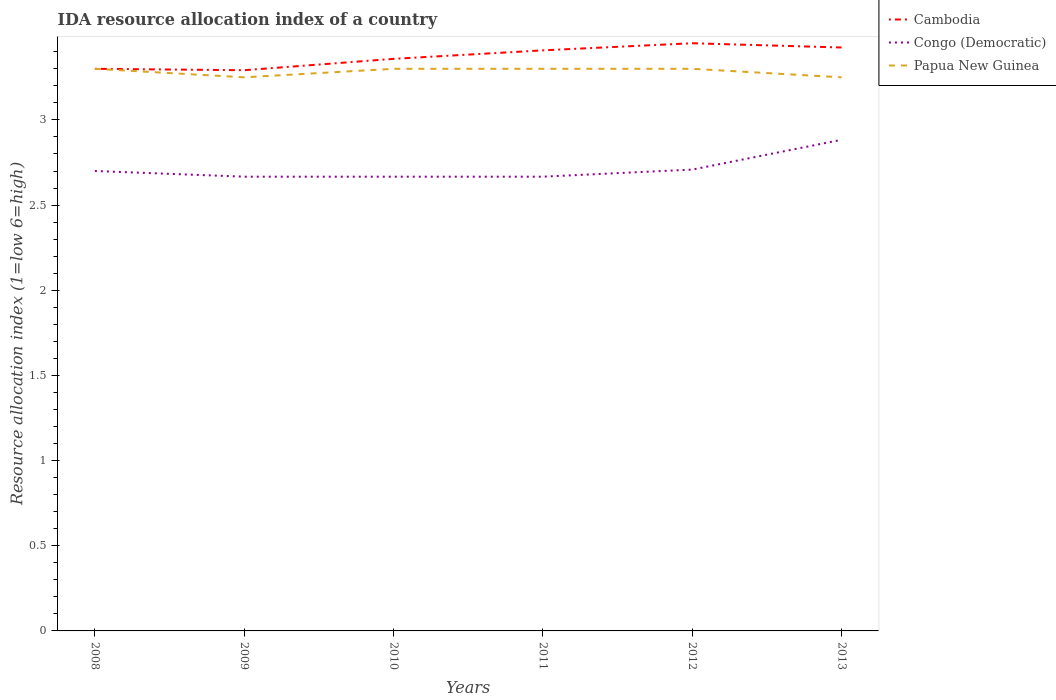How many different coloured lines are there?
Provide a short and direct response. 3. Is the number of lines equal to the number of legend labels?
Your response must be concise. Yes. Across all years, what is the maximum IDA resource allocation index in Papua New Guinea?
Offer a very short reply. 3.25. What is the total IDA resource allocation index in Congo (Democratic) in the graph?
Give a very brief answer. 0.03. What is the difference between the highest and the second highest IDA resource allocation index in Cambodia?
Your answer should be very brief. 0.16. What is the difference between the highest and the lowest IDA resource allocation index in Congo (Democratic)?
Offer a very short reply. 1. How many lines are there?
Your answer should be compact. 3. How many years are there in the graph?
Give a very brief answer. 6. Does the graph contain any zero values?
Offer a terse response. No. Where does the legend appear in the graph?
Offer a terse response. Top right. What is the title of the graph?
Give a very brief answer. IDA resource allocation index of a country. What is the label or title of the Y-axis?
Provide a succinct answer. Resource allocation index (1=low 6=high). What is the Resource allocation index (1=low 6=high) of Congo (Democratic) in 2008?
Give a very brief answer. 2.7. What is the Resource allocation index (1=low 6=high) in Cambodia in 2009?
Provide a succinct answer. 3.29. What is the Resource allocation index (1=low 6=high) of Congo (Democratic) in 2009?
Keep it short and to the point. 2.67. What is the Resource allocation index (1=low 6=high) of Cambodia in 2010?
Ensure brevity in your answer.  3.36. What is the Resource allocation index (1=low 6=high) of Congo (Democratic) in 2010?
Ensure brevity in your answer.  2.67. What is the Resource allocation index (1=low 6=high) in Papua New Guinea in 2010?
Your response must be concise. 3.3. What is the Resource allocation index (1=low 6=high) in Cambodia in 2011?
Keep it short and to the point. 3.41. What is the Resource allocation index (1=low 6=high) in Congo (Democratic) in 2011?
Your response must be concise. 2.67. What is the Resource allocation index (1=low 6=high) in Cambodia in 2012?
Your answer should be compact. 3.45. What is the Resource allocation index (1=low 6=high) of Congo (Democratic) in 2012?
Provide a short and direct response. 2.71. What is the Resource allocation index (1=low 6=high) of Cambodia in 2013?
Offer a very short reply. 3.42. What is the Resource allocation index (1=low 6=high) of Congo (Democratic) in 2013?
Your answer should be very brief. 2.88. Across all years, what is the maximum Resource allocation index (1=low 6=high) of Cambodia?
Provide a short and direct response. 3.45. Across all years, what is the maximum Resource allocation index (1=low 6=high) in Congo (Democratic)?
Ensure brevity in your answer.  2.88. Across all years, what is the minimum Resource allocation index (1=low 6=high) in Cambodia?
Make the answer very short. 3.29. Across all years, what is the minimum Resource allocation index (1=low 6=high) in Congo (Democratic)?
Your answer should be very brief. 2.67. Across all years, what is the minimum Resource allocation index (1=low 6=high) in Papua New Guinea?
Your response must be concise. 3.25. What is the total Resource allocation index (1=low 6=high) in Cambodia in the graph?
Offer a very short reply. 20.23. What is the total Resource allocation index (1=low 6=high) of Congo (Democratic) in the graph?
Offer a very short reply. 16.29. What is the total Resource allocation index (1=low 6=high) of Papua New Guinea in the graph?
Your answer should be very brief. 19.7. What is the difference between the Resource allocation index (1=low 6=high) in Cambodia in 2008 and that in 2009?
Provide a succinct answer. 0.01. What is the difference between the Resource allocation index (1=low 6=high) in Papua New Guinea in 2008 and that in 2009?
Your answer should be compact. 0.05. What is the difference between the Resource allocation index (1=low 6=high) of Cambodia in 2008 and that in 2010?
Provide a short and direct response. -0.06. What is the difference between the Resource allocation index (1=low 6=high) in Papua New Guinea in 2008 and that in 2010?
Your response must be concise. 0. What is the difference between the Resource allocation index (1=low 6=high) in Cambodia in 2008 and that in 2011?
Your answer should be compact. -0.11. What is the difference between the Resource allocation index (1=low 6=high) of Congo (Democratic) in 2008 and that in 2011?
Provide a succinct answer. 0.03. What is the difference between the Resource allocation index (1=low 6=high) in Congo (Democratic) in 2008 and that in 2012?
Give a very brief answer. -0.01. What is the difference between the Resource allocation index (1=low 6=high) of Cambodia in 2008 and that in 2013?
Your answer should be very brief. -0.12. What is the difference between the Resource allocation index (1=low 6=high) of Congo (Democratic) in 2008 and that in 2013?
Your response must be concise. -0.18. What is the difference between the Resource allocation index (1=low 6=high) in Papua New Guinea in 2008 and that in 2013?
Keep it short and to the point. 0.05. What is the difference between the Resource allocation index (1=low 6=high) in Cambodia in 2009 and that in 2010?
Keep it short and to the point. -0.07. What is the difference between the Resource allocation index (1=low 6=high) in Congo (Democratic) in 2009 and that in 2010?
Your response must be concise. 0. What is the difference between the Resource allocation index (1=low 6=high) in Cambodia in 2009 and that in 2011?
Offer a terse response. -0.12. What is the difference between the Resource allocation index (1=low 6=high) in Papua New Guinea in 2009 and that in 2011?
Make the answer very short. -0.05. What is the difference between the Resource allocation index (1=low 6=high) of Cambodia in 2009 and that in 2012?
Give a very brief answer. -0.16. What is the difference between the Resource allocation index (1=low 6=high) in Congo (Democratic) in 2009 and that in 2012?
Keep it short and to the point. -0.04. What is the difference between the Resource allocation index (1=low 6=high) in Papua New Guinea in 2009 and that in 2012?
Your answer should be compact. -0.05. What is the difference between the Resource allocation index (1=low 6=high) in Cambodia in 2009 and that in 2013?
Give a very brief answer. -0.13. What is the difference between the Resource allocation index (1=low 6=high) of Congo (Democratic) in 2009 and that in 2013?
Your answer should be very brief. -0.22. What is the difference between the Resource allocation index (1=low 6=high) in Papua New Guinea in 2009 and that in 2013?
Make the answer very short. 0. What is the difference between the Resource allocation index (1=low 6=high) in Cambodia in 2010 and that in 2011?
Your answer should be compact. -0.05. What is the difference between the Resource allocation index (1=low 6=high) of Papua New Guinea in 2010 and that in 2011?
Give a very brief answer. 0. What is the difference between the Resource allocation index (1=low 6=high) in Cambodia in 2010 and that in 2012?
Provide a short and direct response. -0.09. What is the difference between the Resource allocation index (1=low 6=high) of Congo (Democratic) in 2010 and that in 2012?
Ensure brevity in your answer.  -0.04. What is the difference between the Resource allocation index (1=low 6=high) of Papua New Guinea in 2010 and that in 2012?
Keep it short and to the point. 0. What is the difference between the Resource allocation index (1=low 6=high) of Cambodia in 2010 and that in 2013?
Your answer should be very brief. -0.07. What is the difference between the Resource allocation index (1=low 6=high) in Congo (Democratic) in 2010 and that in 2013?
Make the answer very short. -0.22. What is the difference between the Resource allocation index (1=low 6=high) of Cambodia in 2011 and that in 2012?
Keep it short and to the point. -0.04. What is the difference between the Resource allocation index (1=low 6=high) in Congo (Democratic) in 2011 and that in 2012?
Offer a terse response. -0.04. What is the difference between the Resource allocation index (1=low 6=high) of Papua New Guinea in 2011 and that in 2012?
Your answer should be compact. 0. What is the difference between the Resource allocation index (1=low 6=high) of Cambodia in 2011 and that in 2013?
Your response must be concise. -0.02. What is the difference between the Resource allocation index (1=low 6=high) of Congo (Democratic) in 2011 and that in 2013?
Your answer should be compact. -0.22. What is the difference between the Resource allocation index (1=low 6=high) in Cambodia in 2012 and that in 2013?
Provide a succinct answer. 0.03. What is the difference between the Resource allocation index (1=low 6=high) in Congo (Democratic) in 2012 and that in 2013?
Ensure brevity in your answer.  -0.17. What is the difference between the Resource allocation index (1=low 6=high) in Papua New Guinea in 2012 and that in 2013?
Provide a short and direct response. 0.05. What is the difference between the Resource allocation index (1=low 6=high) in Cambodia in 2008 and the Resource allocation index (1=low 6=high) in Congo (Democratic) in 2009?
Offer a very short reply. 0.63. What is the difference between the Resource allocation index (1=low 6=high) of Cambodia in 2008 and the Resource allocation index (1=low 6=high) of Papua New Guinea in 2009?
Ensure brevity in your answer.  0.05. What is the difference between the Resource allocation index (1=low 6=high) of Congo (Democratic) in 2008 and the Resource allocation index (1=low 6=high) of Papua New Guinea in 2009?
Your answer should be very brief. -0.55. What is the difference between the Resource allocation index (1=low 6=high) of Cambodia in 2008 and the Resource allocation index (1=low 6=high) of Congo (Democratic) in 2010?
Ensure brevity in your answer.  0.63. What is the difference between the Resource allocation index (1=low 6=high) of Cambodia in 2008 and the Resource allocation index (1=low 6=high) of Papua New Guinea in 2010?
Offer a terse response. 0. What is the difference between the Resource allocation index (1=low 6=high) of Congo (Democratic) in 2008 and the Resource allocation index (1=low 6=high) of Papua New Guinea in 2010?
Offer a terse response. -0.6. What is the difference between the Resource allocation index (1=low 6=high) of Cambodia in 2008 and the Resource allocation index (1=low 6=high) of Congo (Democratic) in 2011?
Offer a very short reply. 0.63. What is the difference between the Resource allocation index (1=low 6=high) in Cambodia in 2008 and the Resource allocation index (1=low 6=high) in Congo (Democratic) in 2012?
Provide a short and direct response. 0.59. What is the difference between the Resource allocation index (1=low 6=high) of Congo (Democratic) in 2008 and the Resource allocation index (1=low 6=high) of Papua New Guinea in 2012?
Your response must be concise. -0.6. What is the difference between the Resource allocation index (1=low 6=high) in Cambodia in 2008 and the Resource allocation index (1=low 6=high) in Congo (Democratic) in 2013?
Your response must be concise. 0.42. What is the difference between the Resource allocation index (1=low 6=high) of Congo (Democratic) in 2008 and the Resource allocation index (1=low 6=high) of Papua New Guinea in 2013?
Offer a very short reply. -0.55. What is the difference between the Resource allocation index (1=low 6=high) in Cambodia in 2009 and the Resource allocation index (1=low 6=high) in Congo (Democratic) in 2010?
Keep it short and to the point. 0.62. What is the difference between the Resource allocation index (1=low 6=high) in Cambodia in 2009 and the Resource allocation index (1=low 6=high) in Papua New Guinea in 2010?
Your answer should be very brief. -0.01. What is the difference between the Resource allocation index (1=low 6=high) in Congo (Democratic) in 2009 and the Resource allocation index (1=low 6=high) in Papua New Guinea in 2010?
Make the answer very short. -0.63. What is the difference between the Resource allocation index (1=low 6=high) in Cambodia in 2009 and the Resource allocation index (1=low 6=high) in Papua New Guinea in 2011?
Make the answer very short. -0.01. What is the difference between the Resource allocation index (1=low 6=high) in Congo (Democratic) in 2009 and the Resource allocation index (1=low 6=high) in Papua New Guinea in 2011?
Your answer should be compact. -0.63. What is the difference between the Resource allocation index (1=low 6=high) of Cambodia in 2009 and the Resource allocation index (1=low 6=high) of Congo (Democratic) in 2012?
Make the answer very short. 0.58. What is the difference between the Resource allocation index (1=low 6=high) of Cambodia in 2009 and the Resource allocation index (1=low 6=high) of Papua New Guinea in 2012?
Keep it short and to the point. -0.01. What is the difference between the Resource allocation index (1=low 6=high) of Congo (Democratic) in 2009 and the Resource allocation index (1=low 6=high) of Papua New Guinea in 2012?
Your answer should be very brief. -0.63. What is the difference between the Resource allocation index (1=low 6=high) in Cambodia in 2009 and the Resource allocation index (1=low 6=high) in Congo (Democratic) in 2013?
Provide a succinct answer. 0.41. What is the difference between the Resource allocation index (1=low 6=high) of Cambodia in 2009 and the Resource allocation index (1=low 6=high) of Papua New Guinea in 2013?
Offer a very short reply. 0.04. What is the difference between the Resource allocation index (1=low 6=high) in Congo (Democratic) in 2009 and the Resource allocation index (1=low 6=high) in Papua New Guinea in 2013?
Offer a terse response. -0.58. What is the difference between the Resource allocation index (1=low 6=high) of Cambodia in 2010 and the Resource allocation index (1=low 6=high) of Congo (Democratic) in 2011?
Your answer should be compact. 0.69. What is the difference between the Resource allocation index (1=low 6=high) of Cambodia in 2010 and the Resource allocation index (1=low 6=high) of Papua New Guinea in 2011?
Offer a very short reply. 0.06. What is the difference between the Resource allocation index (1=low 6=high) of Congo (Democratic) in 2010 and the Resource allocation index (1=low 6=high) of Papua New Guinea in 2011?
Your answer should be very brief. -0.63. What is the difference between the Resource allocation index (1=low 6=high) of Cambodia in 2010 and the Resource allocation index (1=low 6=high) of Congo (Democratic) in 2012?
Offer a very short reply. 0.65. What is the difference between the Resource allocation index (1=low 6=high) of Cambodia in 2010 and the Resource allocation index (1=low 6=high) of Papua New Guinea in 2012?
Ensure brevity in your answer.  0.06. What is the difference between the Resource allocation index (1=low 6=high) of Congo (Democratic) in 2010 and the Resource allocation index (1=low 6=high) of Papua New Guinea in 2012?
Offer a very short reply. -0.63. What is the difference between the Resource allocation index (1=low 6=high) of Cambodia in 2010 and the Resource allocation index (1=low 6=high) of Congo (Democratic) in 2013?
Your answer should be compact. 0.47. What is the difference between the Resource allocation index (1=low 6=high) in Cambodia in 2010 and the Resource allocation index (1=low 6=high) in Papua New Guinea in 2013?
Ensure brevity in your answer.  0.11. What is the difference between the Resource allocation index (1=low 6=high) of Congo (Democratic) in 2010 and the Resource allocation index (1=low 6=high) of Papua New Guinea in 2013?
Give a very brief answer. -0.58. What is the difference between the Resource allocation index (1=low 6=high) of Cambodia in 2011 and the Resource allocation index (1=low 6=high) of Congo (Democratic) in 2012?
Ensure brevity in your answer.  0.7. What is the difference between the Resource allocation index (1=low 6=high) of Cambodia in 2011 and the Resource allocation index (1=low 6=high) of Papua New Guinea in 2012?
Offer a very short reply. 0.11. What is the difference between the Resource allocation index (1=low 6=high) in Congo (Democratic) in 2011 and the Resource allocation index (1=low 6=high) in Papua New Guinea in 2012?
Ensure brevity in your answer.  -0.63. What is the difference between the Resource allocation index (1=low 6=high) of Cambodia in 2011 and the Resource allocation index (1=low 6=high) of Congo (Democratic) in 2013?
Your response must be concise. 0.53. What is the difference between the Resource allocation index (1=low 6=high) in Cambodia in 2011 and the Resource allocation index (1=low 6=high) in Papua New Guinea in 2013?
Provide a short and direct response. 0.16. What is the difference between the Resource allocation index (1=low 6=high) of Congo (Democratic) in 2011 and the Resource allocation index (1=low 6=high) of Papua New Guinea in 2013?
Provide a succinct answer. -0.58. What is the difference between the Resource allocation index (1=low 6=high) in Cambodia in 2012 and the Resource allocation index (1=low 6=high) in Congo (Democratic) in 2013?
Provide a succinct answer. 0.57. What is the difference between the Resource allocation index (1=low 6=high) in Congo (Democratic) in 2012 and the Resource allocation index (1=low 6=high) in Papua New Guinea in 2013?
Offer a terse response. -0.54. What is the average Resource allocation index (1=low 6=high) in Cambodia per year?
Provide a succinct answer. 3.37. What is the average Resource allocation index (1=low 6=high) in Congo (Democratic) per year?
Provide a short and direct response. 2.72. What is the average Resource allocation index (1=low 6=high) of Papua New Guinea per year?
Your answer should be compact. 3.28. In the year 2008, what is the difference between the Resource allocation index (1=low 6=high) of Cambodia and Resource allocation index (1=low 6=high) of Papua New Guinea?
Ensure brevity in your answer.  0. In the year 2009, what is the difference between the Resource allocation index (1=low 6=high) in Cambodia and Resource allocation index (1=low 6=high) in Congo (Democratic)?
Make the answer very short. 0.62. In the year 2009, what is the difference between the Resource allocation index (1=low 6=high) in Cambodia and Resource allocation index (1=low 6=high) in Papua New Guinea?
Ensure brevity in your answer.  0.04. In the year 2009, what is the difference between the Resource allocation index (1=low 6=high) of Congo (Democratic) and Resource allocation index (1=low 6=high) of Papua New Guinea?
Offer a terse response. -0.58. In the year 2010, what is the difference between the Resource allocation index (1=low 6=high) of Cambodia and Resource allocation index (1=low 6=high) of Congo (Democratic)?
Provide a succinct answer. 0.69. In the year 2010, what is the difference between the Resource allocation index (1=low 6=high) in Cambodia and Resource allocation index (1=low 6=high) in Papua New Guinea?
Provide a succinct answer. 0.06. In the year 2010, what is the difference between the Resource allocation index (1=low 6=high) of Congo (Democratic) and Resource allocation index (1=low 6=high) of Papua New Guinea?
Offer a terse response. -0.63. In the year 2011, what is the difference between the Resource allocation index (1=low 6=high) in Cambodia and Resource allocation index (1=low 6=high) in Congo (Democratic)?
Offer a very short reply. 0.74. In the year 2011, what is the difference between the Resource allocation index (1=low 6=high) of Cambodia and Resource allocation index (1=low 6=high) of Papua New Guinea?
Keep it short and to the point. 0.11. In the year 2011, what is the difference between the Resource allocation index (1=low 6=high) of Congo (Democratic) and Resource allocation index (1=low 6=high) of Papua New Guinea?
Make the answer very short. -0.63. In the year 2012, what is the difference between the Resource allocation index (1=low 6=high) in Cambodia and Resource allocation index (1=low 6=high) in Congo (Democratic)?
Your response must be concise. 0.74. In the year 2012, what is the difference between the Resource allocation index (1=low 6=high) in Congo (Democratic) and Resource allocation index (1=low 6=high) in Papua New Guinea?
Offer a terse response. -0.59. In the year 2013, what is the difference between the Resource allocation index (1=low 6=high) in Cambodia and Resource allocation index (1=low 6=high) in Congo (Democratic)?
Offer a very short reply. 0.54. In the year 2013, what is the difference between the Resource allocation index (1=low 6=high) of Cambodia and Resource allocation index (1=low 6=high) of Papua New Guinea?
Provide a short and direct response. 0.17. In the year 2013, what is the difference between the Resource allocation index (1=low 6=high) of Congo (Democratic) and Resource allocation index (1=low 6=high) of Papua New Guinea?
Offer a terse response. -0.37. What is the ratio of the Resource allocation index (1=low 6=high) in Congo (Democratic) in 2008 to that in 2009?
Offer a very short reply. 1.01. What is the ratio of the Resource allocation index (1=low 6=high) in Papua New Guinea in 2008 to that in 2009?
Keep it short and to the point. 1.02. What is the ratio of the Resource allocation index (1=low 6=high) in Cambodia in 2008 to that in 2010?
Ensure brevity in your answer.  0.98. What is the ratio of the Resource allocation index (1=low 6=high) of Congo (Democratic) in 2008 to that in 2010?
Ensure brevity in your answer.  1.01. What is the ratio of the Resource allocation index (1=low 6=high) of Cambodia in 2008 to that in 2011?
Make the answer very short. 0.97. What is the ratio of the Resource allocation index (1=low 6=high) of Congo (Democratic) in 2008 to that in 2011?
Make the answer very short. 1.01. What is the ratio of the Resource allocation index (1=low 6=high) of Papua New Guinea in 2008 to that in 2011?
Offer a very short reply. 1. What is the ratio of the Resource allocation index (1=low 6=high) of Cambodia in 2008 to that in 2012?
Give a very brief answer. 0.96. What is the ratio of the Resource allocation index (1=low 6=high) of Cambodia in 2008 to that in 2013?
Keep it short and to the point. 0.96. What is the ratio of the Resource allocation index (1=low 6=high) of Congo (Democratic) in 2008 to that in 2013?
Provide a succinct answer. 0.94. What is the ratio of the Resource allocation index (1=low 6=high) in Papua New Guinea in 2008 to that in 2013?
Provide a succinct answer. 1.02. What is the ratio of the Resource allocation index (1=low 6=high) of Cambodia in 2009 to that in 2010?
Keep it short and to the point. 0.98. What is the ratio of the Resource allocation index (1=low 6=high) in Cambodia in 2009 to that in 2011?
Provide a succinct answer. 0.97. What is the ratio of the Resource allocation index (1=low 6=high) of Papua New Guinea in 2009 to that in 2011?
Your answer should be compact. 0.98. What is the ratio of the Resource allocation index (1=low 6=high) in Cambodia in 2009 to that in 2012?
Provide a short and direct response. 0.95. What is the ratio of the Resource allocation index (1=low 6=high) in Congo (Democratic) in 2009 to that in 2012?
Give a very brief answer. 0.98. What is the ratio of the Resource allocation index (1=low 6=high) of Cambodia in 2009 to that in 2013?
Offer a very short reply. 0.96. What is the ratio of the Resource allocation index (1=low 6=high) of Congo (Democratic) in 2009 to that in 2013?
Provide a succinct answer. 0.92. What is the ratio of the Resource allocation index (1=low 6=high) of Papua New Guinea in 2009 to that in 2013?
Provide a short and direct response. 1. What is the ratio of the Resource allocation index (1=low 6=high) in Papua New Guinea in 2010 to that in 2011?
Your response must be concise. 1. What is the ratio of the Resource allocation index (1=low 6=high) in Cambodia in 2010 to that in 2012?
Make the answer very short. 0.97. What is the ratio of the Resource allocation index (1=low 6=high) of Congo (Democratic) in 2010 to that in 2012?
Provide a succinct answer. 0.98. What is the ratio of the Resource allocation index (1=low 6=high) of Cambodia in 2010 to that in 2013?
Give a very brief answer. 0.98. What is the ratio of the Resource allocation index (1=low 6=high) of Congo (Democratic) in 2010 to that in 2013?
Your answer should be very brief. 0.92. What is the ratio of the Resource allocation index (1=low 6=high) in Papua New Guinea in 2010 to that in 2013?
Provide a short and direct response. 1.02. What is the ratio of the Resource allocation index (1=low 6=high) of Cambodia in 2011 to that in 2012?
Offer a terse response. 0.99. What is the ratio of the Resource allocation index (1=low 6=high) of Congo (Democratic) in 2011 to that in 2012?
Keep it short and to the point. 0.98. What is the ratio of the Resource allocation index (1=low 6=high) in Congo (Democratic) in 2011 to that in 2013?
Keep it short and to the point. 0.92. What is the ratio of the Resource allocation index (1=low 6=high) of Papua New Guinea in 2011 to that in 2013?
Your response must be concise. 1.02. What is the ratio of the Resource allocation index (1=low 6=high) of Cambodia in 2012 to that in 2013?
Ensure brevity in your answer.  1.01. What is the ratio of the Resource allocation index (1=low 6=high) in Congo (Democratic) in 2012 to that in 2013?
Ensure brevity in your answer.  0.94. What is the ratio of the Resource allocation index (1=low 6=high) in Papua New Guinea in 2012 to that in 2013?
Keep it short and to the point. 1.02. What is the difference between the highest and the second highest Resource allocation index (1=low 6=high) of Cambodia?
Your response must be concise. 0.03. What is the difference between the highest and the second highest Resource allocation index (1=low 6=high) of Congo (Democratic)?
Make the answer very short. 0.17. What is the difference between the highest and the second highest Resource allocation index (1=low 6=high) of Papua New Guinea?
Offer a very short reply. 0. What is the difference between the highest and the lowest Resource allocation index (1=low 6=high) in Cambodia?
Keep it short and to the point. 0.16. What is the difference between the highest and the lowest Resource allocation index (1=low 6=high) in Congo (Democratic)?
Your answer should be compact. 0.22. 